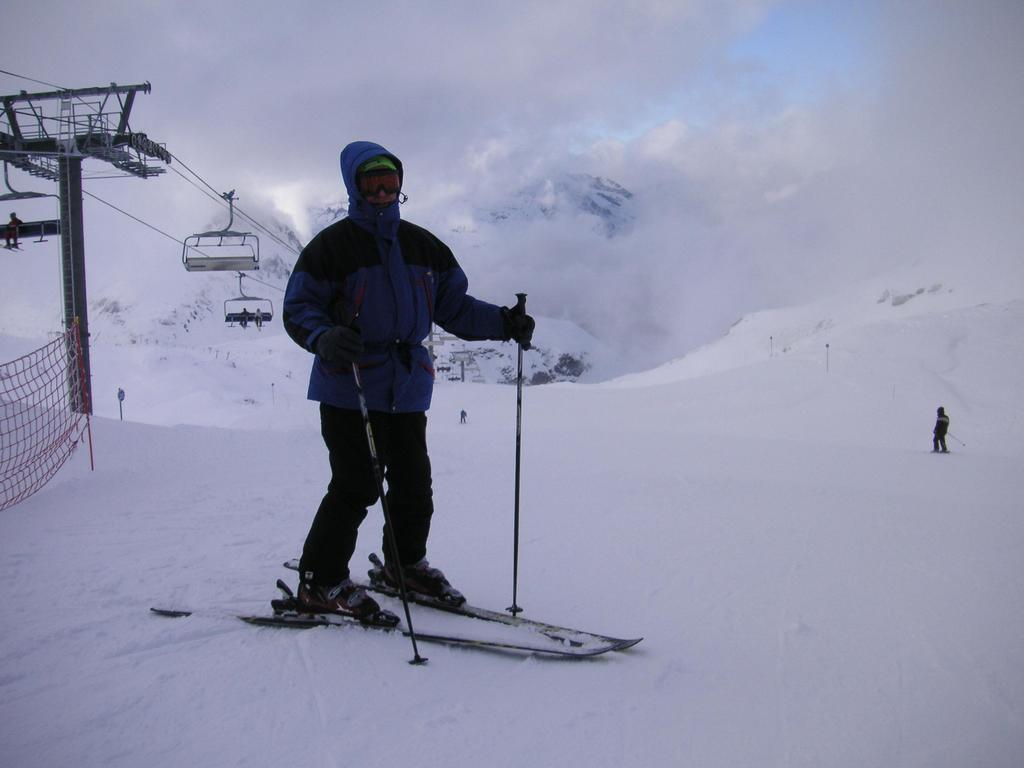Describe this image in one or two sentences. In this image we can see people standing on the snow on the ski boards. In the background there are sky, mountains, net and persons sitting in the ropeway. 